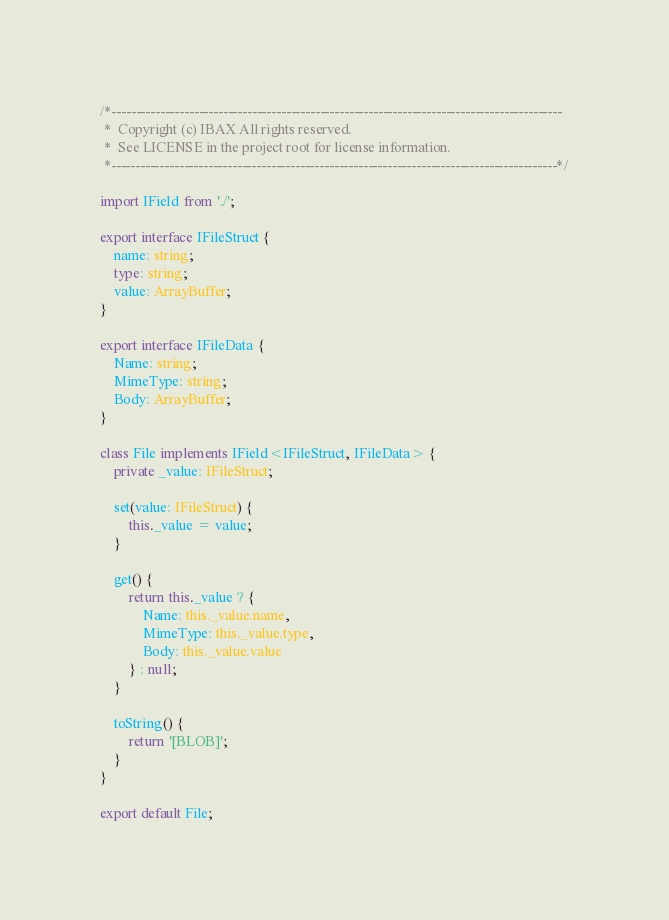Convert code to text. <code><loc_0><loc_0><loc_500><loc_500><_TypeScript_>/*---------------------------------------------------------------------------------------------
 *  Copyright (c) IBAX All rights reserved.
 *  See LICENSE in the project root for license information.
 *--------------------------------------------------------------------------------------------*/

import IField from './';

export interface IFileStruct {
    name: string;
    type: string;
    value: ArrayBuffer;
}

export interface IFileData {
    Name: string;
    MimeType: string;
    Body: ArrayBuffer;
}

class File implements IField<IFileStruct, IFileData> {
    private _value: IFileStruct;

    set(value: IFileStruct) {
        this._value = value;
    }

    get() {
        return this._value ? {
            Name: this._value.name,
            MimeType: this._value.type,
            Body: this._value.value
        } : null;
    }

    toString() {
        return '[BLOB]';
    }
}

export default File;</code> 